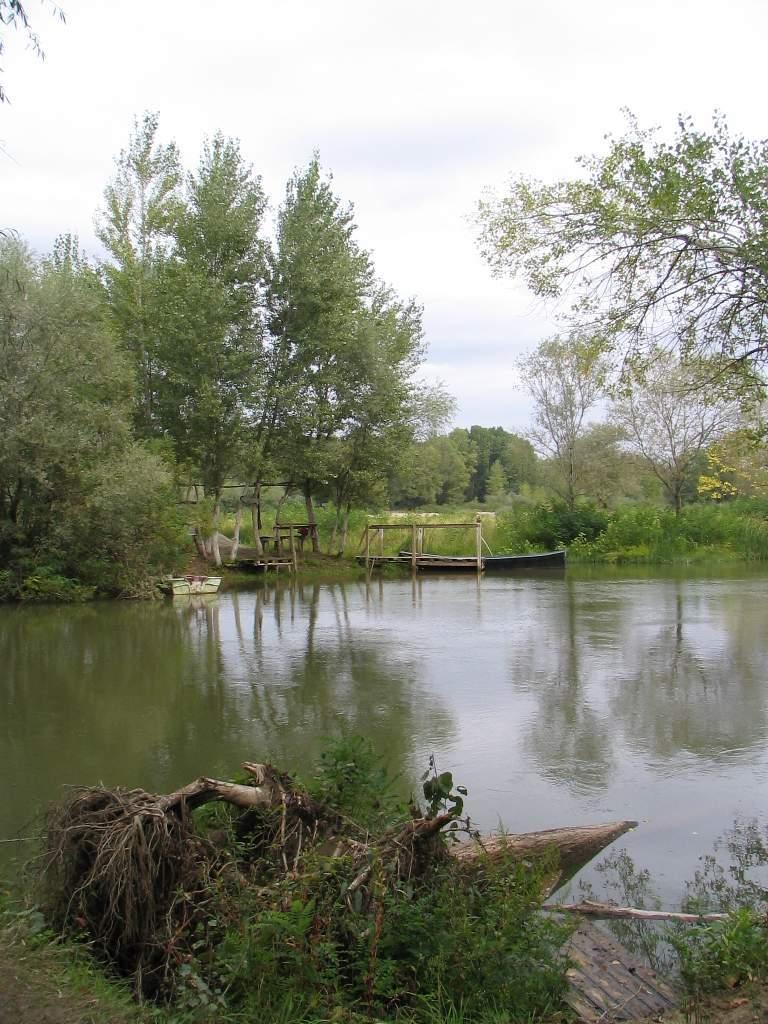Could you give a brief overview of what you see in this image? In this image we can see trees, plants, water, boat and wooden logs. At the top of the image we can see the sky. 